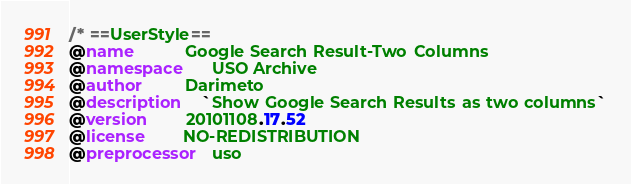<code> <loc_0><loc_0><loc_500><loc_500><_CSS_>/* ==UserStyle==
@name           Google Search Result-Two Columns
@namespace      USO Archive
@author         Darimeto
@description    `Show Google Search Results as two columns`
@version        20101108.17.52
@license        NO-REDISTRIBUTION
@preprocessor   uso</code> 